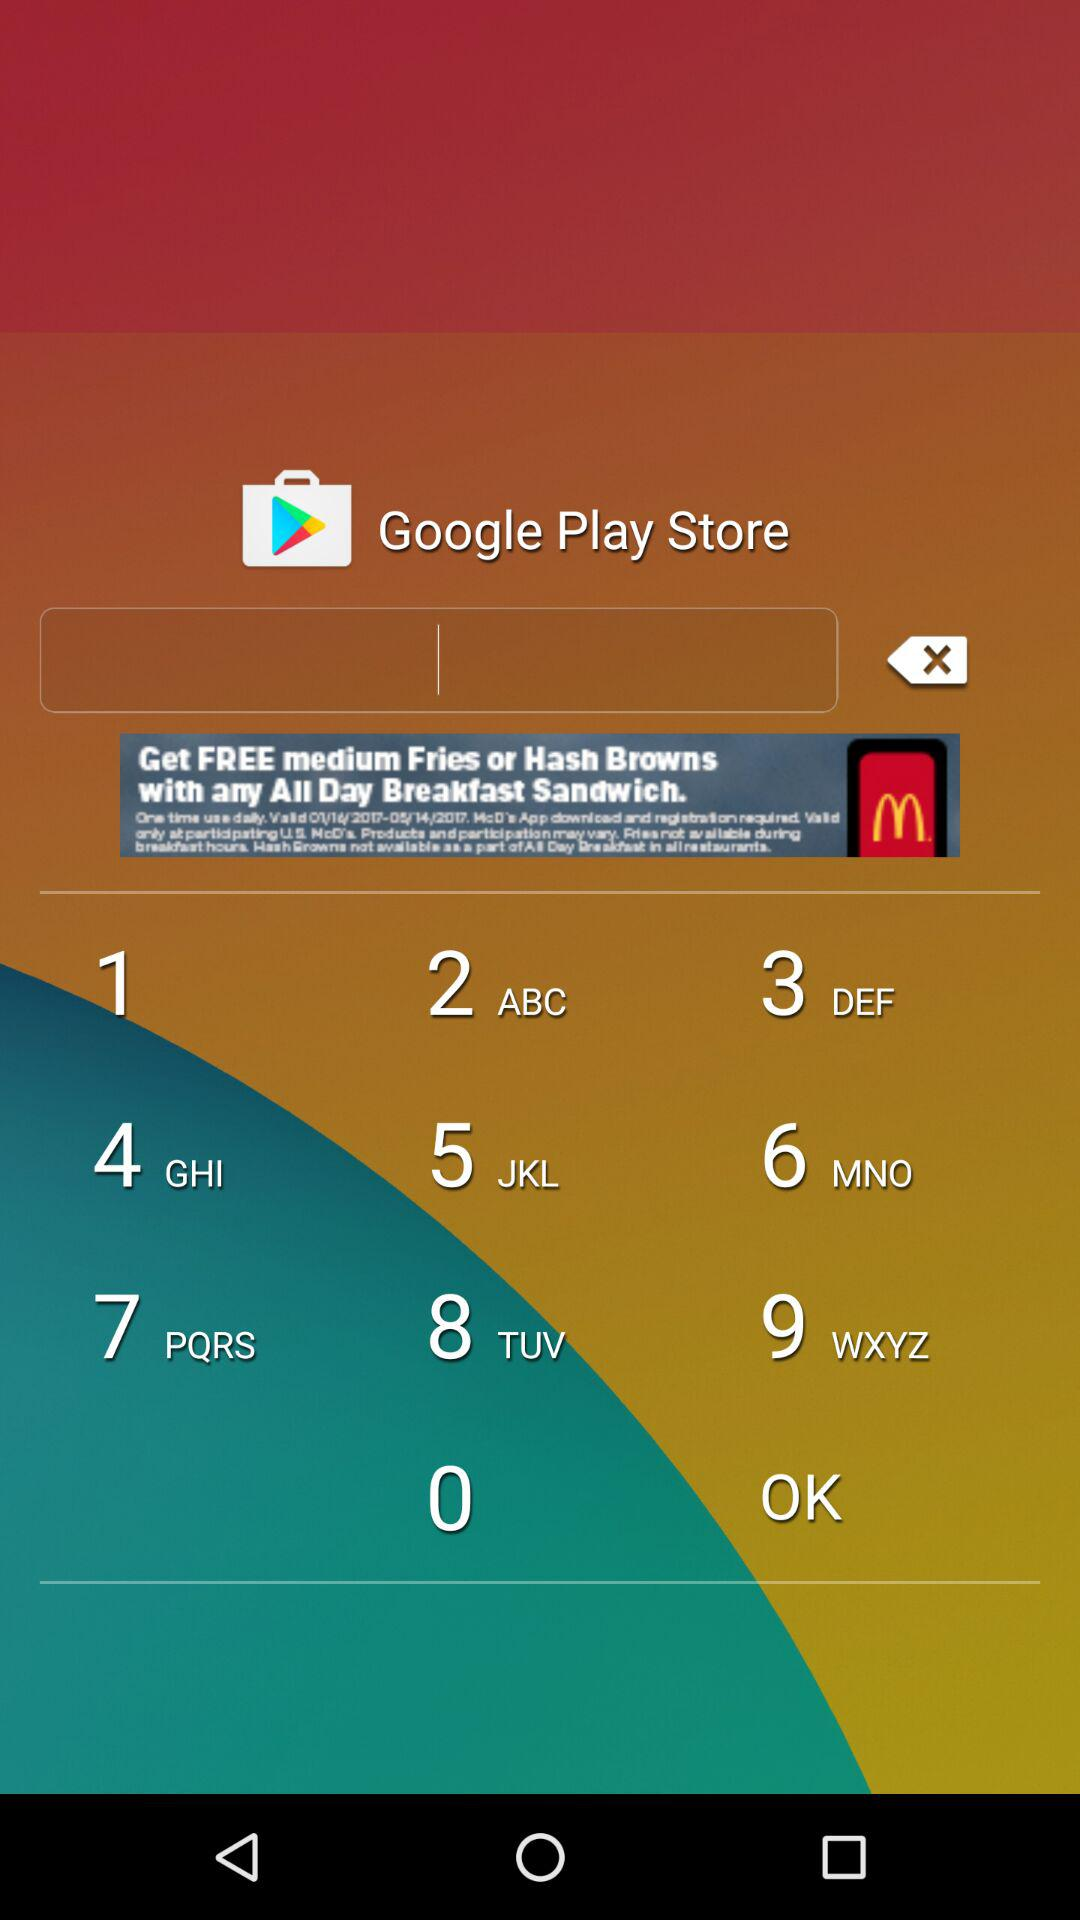How much does "Bubble Shooter Deluxe" cost?
When the provided information is insufficient, respond with <no answer>. <no answer> 